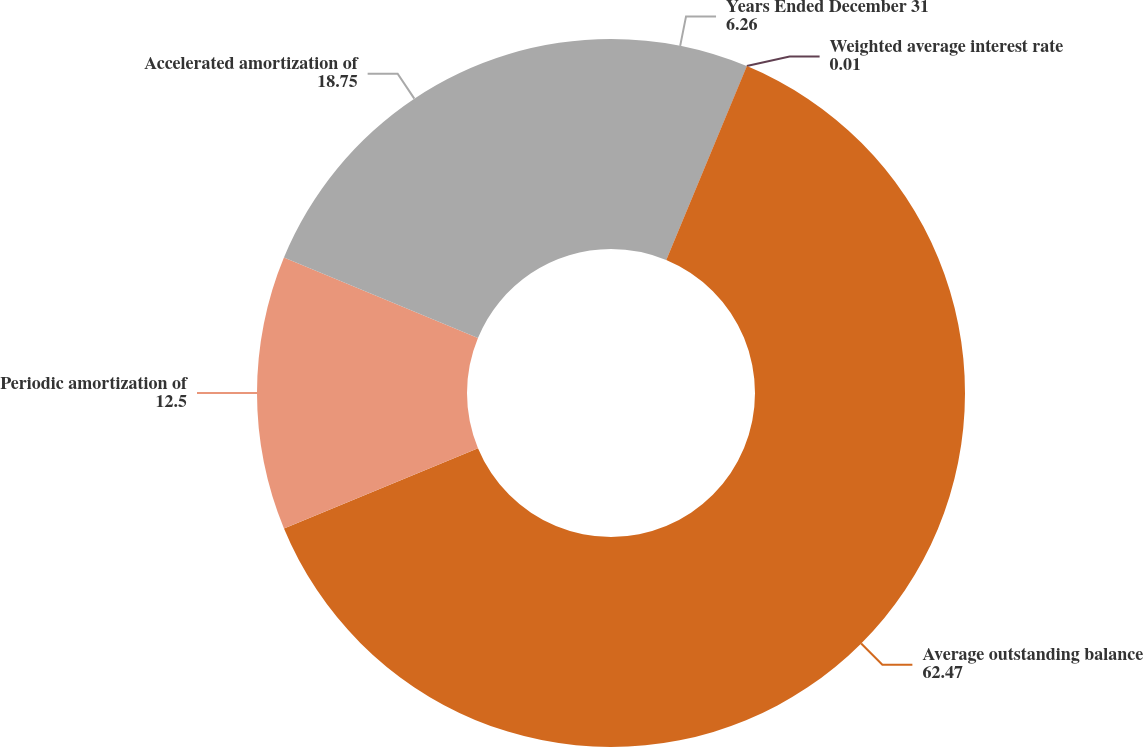<chart> <loc_0><loc_0><loc_500><loc_500><pie_chart><fcel>Years Ended December 31<fcel>Weighted average interest rate<fcel>Average outstanding balance<fcel>Periodic amortization of<fcel>Accelerated amortization of<nl><fcel>6.26%<fcel>0.01%<fcel>62.47%<fcel>12.5%<fcel>18.75%<nl></chart> 